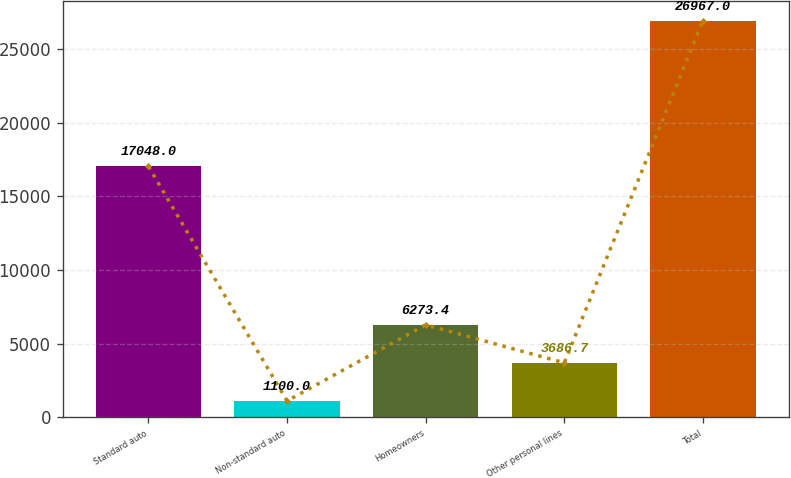<chart> <loc_0><loc_0><loc_500><loc_500><bar_chart><fcel>Standard auto<fcel>Non-standard auto<fcel>Homeowners<fcel>Other personal lines<fcel>Total<nl><fcel>17048<fcel>1100<fcel>6273.4<fcel>3686.7<fcel>26967<nl></chart> 